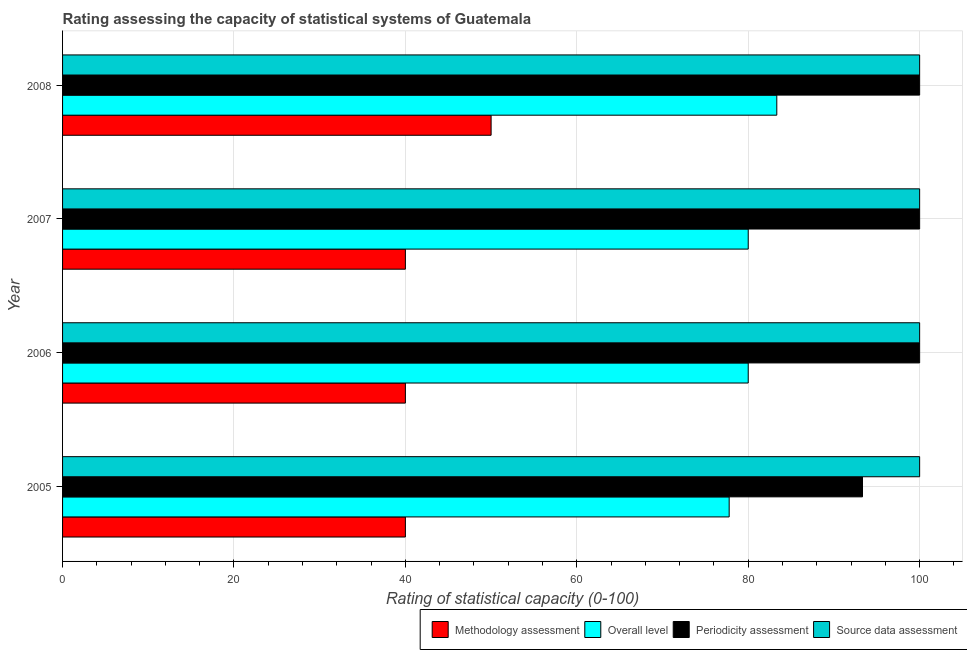How many groups of bars are there?
Ensure brevity in your answer.  4. Are the number of bars per tick equal to the number of legend labels?
Make the answer very short. Yes. Are the number of bars on each tick of the Y-axis equal?
Keep it short and to the point. Yes. How many bars are there on the 2nd tick from the bottom?
Offer a very short reply. 4. What is the label of the 4th group of bars from the top?
Your answer should be very brief. 2005. In how many cases, is the number of bars for a given year not equal to the number of legend labels?
Provide a short and direct response. 0. What is the source data assessment rating in 2008?
Your response must be concise. 100. Across all years, what is the maximum methodology assessment rating?
Ensure brevity in your answer.  50. Across all years, what is the minimum periodicity assessment rating?
Your answer should be compact. 93.33. In which year was the methodology assessment rating maximum?
Give a very brief answer. 2008. What is the total overall level rating in the graph?
Keep it short and to the point. 321.11. What is the difference between the source data assessment rating in 2006 and that in 2007?
Your answer should be compact. 0. What is the difference between the methodology assessment rating in 2005 and the overall level rating in 2006?
Offer a terse response. -40. In the year 2007, what is the difference between the periodicity assessment rating and methodology assessment rating?
Your answer should be very brief. 60. In how many years, is the periodicity assessment rating greater than 60 ?
Provide a short and direct response. 4. What is the ratio of the source data assessment rating in 2006 to that in 2007?
Make the answer very short. 1. What is the difference between the highest and the second highest overall level rating?
Your response must be concise. 3.33. What is the difference between the highest and the lowest periodicity assessment rating?
Keep it short and to the point. 6.67. In how many years, is the periodicity assessment rating greater than the average periodicity assessment rating taken over all years?
Provide a short and direct response. 3. What does the 1st bar from the top in 2007 represents?
Give a very brief answer. Source data assessment. What does the 1st bar from the bottom in 2006 represents?
Give a very brief answer. Methodology assessment. Are all the bars in the graph horizontal?
Ensure brevity in your answer.  Yes. How many years are there in the graph?
Your answer should be compact. 4. Are the values on the major ticks of X-axis written in scientific E-notation?
Provide a succinct answer. No. How are the legend labels stacked?
Offer a terse response. Horizontal. What is the title of the graph?
Provide a short and direct response. Rating assessing the capacity of statistical systems of Guatemala. What is the label or title of the X-axis?
Your answer should be compact. Rating of statistical capacity (0-100). What is the label or title of the Y-axis?
Give a very brief answer. Year. What is the Rating of statistical capacity (0-100) in Methodology assessment in 2005?
Your response must be concise. 40. What is the Rating of statistical capacity (0-100) of Overall level in 2005?
Keep it short and to the point. 77.78. What is the Rating of statistical capacity (0-100) in Periodicity assessment in 2005?
Make the answer very short. 93.33. What is the Rating of statistical capacity (0-100) in Overall level in 2006?
Ensure brevity in your answer.  80. What is the Rating of statistical capacity (0-100) in Periodicity assessment in 2006?
Offer a very short reply. 100. What is the Rating of statistical capacity (0-100) in Source data assessment in 2006?
Make the answer very short. 100. What is the Rating of statistical capacity (0-100) in Periodicity assessment in 2007?
Keep it short and to the point. 100. What is the Rating of statistical capacity (0-100) in Methodology assessment in 2008?
Offer a very short reply. 50. What is the Rating of statistical capacity (0-100) of Overall level in 2008?
Offer a terse response. 83.33. What is the Rating of statistical capacity (0-100) in Source data assessment in 2008?
Ensure brevity in your answer.  100. Across all years, what is the maximum Rating of statistical capacity (0-100) in Methodology assessment?
Make the answer very short. 50. Across all years, what is the maximum Rating of statistical capacity (0-100) in Overall level?
Your answer should be compact. 83.33. Across all years, what is the maximum Rating of statistical capacity (0-100) of Periodicity assessment?
Offer a terse response. 100. Across all years, what is the minimum Rating of statistical capacity (0-100) in Overall level?
Provide a succinct answer. 77.78. Across all years, what is the minimum Rating of statistical capacity (0-100) of Periodicity assessment?
Give a very brief answer. 93.33. What is the total Rating of statistical capacity (0-100) of Methodology assessment in the graph?
Provide a short and direct response. 170. What is the total Rating of statistical capacity (0-100) of Overall level in the graph?
Your answer should be very brief. 321.11. What is the total Rating of statistical capacity (0-100) in Periodicity assessment in the graph?
Your response must be concise. 393.33. What is the total Rating of statistical capacity (0-100) of Source data assessment in the graph?
Your answer should be very brief. 400. What is the difference between the Rating of statistical capacity (0-100) of Overall level in 2005 and that in 2006?
Keep it short and to the point. -2.22. What is the difference between the Rating of statistical capacity (0-100) of Periodicity assessment in 2005 and that in 2006?
Keep it short and to the point. -6.67. What is the difference between the Rating of statistical capacity (0-100) in Source data assessment in 2005 and that in 2006?
Your response must be concise. 0. What is the difference between the Rating of statistical capacity (0-100) of Overall level in 2005 and that in 2007?
Your answer should be very brief. -2.22. What is the difference between the Rating of statistical capacity (0-100) of Periodicity assessment in 2005 and that in 2007?
Your answer should be very brief. -6.67. What is the difference between the Rating of statistical capacity (0-100) of Methodology assessment in 2005 and that in 2008?
Ensure brevity in your answer.  -10. What is the difference between the Rating of statistical capacity (0-100) in Overall level in 2005 and that in 2008?
Your answer should be very brief. -5.56. What is the difference between the Rating of statistical capacity (0-100) in Periodicity assessment in 2005 and that in 2008?
Ensure brevity in your answer.  -6.67. What is the difference between the Rating of statistical capacity (0-100) in Source data assessment in 2005 and that in 2008?
Give a very brief answer. 0. What is the difference between the Rating of statistical capacity (0-100) in Periodicity assessment in 2006 and that in 2007?
Offer a terse response. 0. What is the difference between the Rating of statistical capacity (0-100) of Methodology assessment in 2006 and that in 2008?
Provide a succinct answer. -10. What is the difference between the Rating of statistical capacity (0-100) in Overall level in 2006 and that in 2008?
Provide a succinct answer. -3.33. What is the difference between the Rating of statistical capacity (0-100) in Source data assessment in 2006 and that in 2008?
Your answer should be compact. 0. What is the difference between the Rating of statistical capacity (0-100) of Methodology assessment in 2007 and that in 2008?
Ensure brevity in your answer.  -10. What is the difference between the Rating of statistical capacity (0-100) of Source data assessment in 2007 and that in 2008?
Ensure brevity in your answer.  0. What is the difference between the Rating of statistical capacity (0-100) in Methodology assessment in 2005 and the Rating of statistical capacity (0-100) in Overall level in 2006?
Your response must be concise. -40. What is the difference between the Rating of statistical capacity (0-100) of Methodology assessment in 2005 and the Rating of statistical capacity (0-100) of Periodicity assessment in 2006?
Your response must be concise. -60. What is the difference between the Rating of statistical capacity (0-100) in Methodology assessment in 2005 and the Rating of statistical capacity (0-100) in Source data assessment in 2006?
Your answer should be very brief. -60. What is the difference between the Rating of statistical capacity (0-100) of Overall level in 2005 and the Rating of statistical capacity (0-100) of Periodicity assessment in 2006?
Your answer should be very brief. -22.22. What is the difference between the Rating of statistical capacity (0-100) of Overall level in 2005 and the Rating of statistical capacity (0-100) of Source data assessment in 2006?
Your response must be concise. -22.22. What is the difference between the Rating of statistical capacity (0-100) of Periodicity assessment in 2005 and the Rating of statistical capacity (0-100) of Source data assessment in 2006?
Give a very brief answer. -6.67. What is the difference between the Rating of statistical capacity (0-100) in Methodology assessment in 2005 and the Rating of statistical capacity (0-100) in Periodicity assessment in 2007?
Your answer should be very brief. -60. What is the difference between the Rating of statistical capacity (0-100) in Methodology assessment in 2005 and the Rating of statistical capacity (0-100) in Source data assessment in 2007?
Ensure brevity in your answer.  -60. What is the difference between the Rating of statistical capacity (0-100) in Overall level in 2005 and the Rating of statistical capacity (0-100) in Periodicity assessment in 2007?
Your answer should be compact. -22.22. What is the difference between the Rating of statistical capacity (0-100) of Overall level in 2005 and the Rating of statistical capacity (0-100) of Source data assessment in 2007?
Ensure brevity in your answer.  -22.22. What is the difference between the Rating of statistical capacity (0-100) in Periodicity assessment in 2005 and the Rating of statistical capacity (0-100) in Source data assessment in 2007?
Offer a terse response. -6.67. What is the difference between the Rating of statistical capacity (0-100) of Methodology assessment in 2005 and the Rating of statistical capacity (0-100) of Overall level in 2008?
Ensure brevity in your answer.  -43.33. What is the difference between the Rating of statistical capacity (0-100) in Methodology assessment in 2005 and the Rating of statistical capacity (0-100) in Periodicity assessment in 2008?
Ensure brevity in your answer.  -60. What is the difference between the Rating of statistical capacity (0-100) of Methodology assessment in 2005 and the Rating of statistical capacity (0-100) of Source data assessment in 2008?
Provide a succinct answer. -60. What is the difference between the Rating of statistical capacity (0-100) of Overall level in 2005 and the Rating of statistical capacity (0-100) of Periodicity assessment in 2008?
Offer a very short reply. -22.22. What is the difference between the Rating of statistical capacity (0-100) in Overall level in 2005 and the Rating of statistical capacity (0-100) in Source data assessment in 2008?
Your answer should be compact. -22.22. What is the difference between the Rating of statistical capacity (0-100) in Periodicity assessment in 2005 and the Rating of statistical capacity (0-100) in Source data assessment in 2008?
Your response must be concise. -6.67. What is the difference between the Rating of statistical capacity (0-100) of Methodology assessment in 2006 and the Rating of statistical capacity (0-100) of Periodicity assessment in 2007?
Ensure brevity in your answer.  -60. What is the difference between the Rating of statistical capacity (0-100) in Methodology assessment in 2006 and the Rating of statistical capacity (0-100) in Source data assessment in 2007?
Keep it short and to the point. -60. What is the difference between the Rating of statistical capacity (0-100) of Overall level in 2006 and the Rating of statistical capacity (0-100) of Periodicity assessment in 2007?
Provide a succinct answer. -20. What is the difference between the Rating of statistical capacity (0-100) of Overall level in 2006 and the Rating of statistical capacity (0-100) of Source data assessment in 2007?
Give a very brief answer. -20. What is the difference between the Rating of statistical capacity (0-100) in Methodology assessment in 2006 and the Rating of statistical capacity (0-100) in Overall level in 2008?
Provide a succinct answer. -43.33. What is the difference between the Rating of statistical capacity (0-100) in Methodology assessment in 2006 and the Rating of statistical capacity (0-100) in Periodicity assessment in 2008?
Provide a succinct answer. -60. What is the difference between the Rating of statistical capacity (0-100) of Methodology assessment in 2006 and the Rating of statistical capacity (0-100) of Source data assessment in 2008?
Offer a terse response. -60. What is the difference between the Rating of statistical capacity (0-100) of Overall level in 2006 and the Rating of statistical capacity (0-100) of Periodicity assessment in 2008?
Make the answer very short. -20. What is the difference between the Rating of statistical capacity (0-100) in Overall level in 2006 and the Rating of statistical capacity (0-100) in Source data assessment in 2008?
Your answer should be compact. -20. What is the difference between the Rating of statistical capacity (0-100) in Methodology assessment in 2007 and the Rating of statistical capacity (0-100) in Overall level in 2008?
Offer a terse response. -43.33. What is the difference between the Rating of statistical capacity (0-100) in Methodology assessment in 2007 and the Rating of statistical capacity (0-100) in Periodicity assessment in 2008?
Keep it short and to the point. -60. What is the difference between the Rating of statistical capacity (0-100) in Methodology assessment in 2007 and the Rating of statistical capacity (0-100) in Source data assessment in 2008?
Provide a succinct answer. -60. What is the difference between the Rating of statistical capacity (0-100) in Overall level in 2007 and the Rating of statistical capacity (0-100) in Source data assessment in 2008?
Provide a short and direct response. -20. What is the difference between the Rating of statistical capacity (0-100) of Periodicity assessment in 2007 and the Rating of statistical capacity (0-100) of Source data assessment in 2008?
Keep it short and to the point. 0. What is the average Rating of statistical capacity (0-100) of Methodology assessment per year?
Offer a terse response. 42.5. What is the average Rating of statistical capacity (0-100) of Overall level per year?
Ensure brevity in your answer.  80.28. What is the average Rating of statistical capacity (0-100) in Periodicity assessment per year?
Provide a short and direct response. 98.33. In the year 2005, what is the difference between the Rating of statistical capacity (0-100) in Methodology assessment and Rating of statistical capacity (0-100) in Overall level?
Your answer should be compact. -37.78. In the year 2005, what is the difference between the Rating of statistical capacity (0-100) of Methodology assessment and Rating of statistical capacity (0-100) of Periodicity assessment?
Make the answer very short. -53.33. In the year 2005, what is the difference between the Rating of statistical capacity (0-100) in Methodology assessment and Rating of statistical capacity (0-100) in Source data assessment?
Make the answer very short. -60. In the year 2005, what is the difference between the Rating of statistical capacity (0-100) in Overall level and Rating of statistical capacity (0-100) in Periodicity assessment?
Offer a very short reply. -15.56. In the year 2005, what is the difference between the Rating of statistical capacity (0-100) in Overall level and Rating of statistical capacity (0-100) in Source data assessment?
Provide a succinct answer. -22.22. In the year 2005, what is the difference between the Rating of statistical capacity (0-100) of Periodicity assessment and Rating of statistical capacity (0-100) of Source data assessment?
Your answer should be compact. -6.67. In the year 2006, what is the difference between the Rating of statistical capacity (0-100) of Methodology assessment and Rating of statistical capacity (0-100) of Overall level?
Ensure brevity in your answer.  -40. In the year 2006, what is the difference between the Rating of statistical capacity (0-100) of Methodology assessment and Rating of statistical capacity (0-100) of Periodicity assessment?
Your answer should be very brief. -60. In the year 2006, what is the difference between the Rating of statistical capacity (0-100) in Methodology assessment and Rating of statistical capacity (0-100) in Source data assessment?
Your answer should be very brief. -60. In the year 2006, what is the difference between the Rating of statistical capacity (0-100) of Overall level and Rating of statistical capacity (0-100) of Source data assessment?
Your answer should be compact. -20. In the year 2006, what is the difference between the Rating of statistical capacity (0-100) of Periodicity assessment and Rating of statistical capacity (0-100) of Source data assessment?
Offer a terse response. 0. In the year 2007, what is the difference between the Rating of statistical capacity (0-100) in Methodology assessment and Rating of statistical capacity (0-100) in Overall level?
Your answer should be very brief. -40. In the year 2007, what is the difference between the Rating of statistical capacity (0-100) of Methodology assessment and Rating of statistical capacity (0-100) of Periodicity assessment?
Your response must be concise. -60. In the year 2007, what is the difference between the Rating of statistical capacity (0-100) in Methodology assessment and Rating of statistical capacity (0-100) in Source data assessment?
Provide a short and direct response. -60. In the year 2007, what is the difference between the Rating of statistical capacity (0-100) in Overall level and Rating of statistical capacity (0-100) in Periodicity assessment?
Provide a succinct answer. -20. In the year 2007, what is the difference between the Rating of statistical capacity (0-100) in Overall level and Rating of statistical capacity (0-100) in Source data assessment?
Offer a terse response. -20. In the year 2008, what is the difference between the Rating of statistical capacity (0-100) in Methodology assessment and Rating of statistical capacity (0-100) in Overall level?
Ensure brevity in your answer.  -33.33. In the year 2008, what is the difference between the Rating of statistical capacity (0-100) in Methodology assessment and Rating of statistical capacity (0-100) in Periodicity assessment?
Your answer should be compact. -50. In the year 2008, what is the difference between the Rating of statistical capacity (0-100) of Overall level and Rating of statistical capacity (0-100) of Periodicity assessment?
Offer a terse response. -16.67. In the year 2008, what is the difference between the Rating of statistical capacity (0-100) in Overall level and Rating of statistical capacity (0-100) in Source data assessment?
Offer a very short reply. -16.67. In the year 2008, what is the difference between the Rating of statistical capacity (0-100) in Periodicity assessment and Rating of statistical capacity (0-100) in Source data assessment?
Ensure brevity in your answer.  0. What is the ratio of the Rating of statistical capacity (0-100) in Methodology assessment in 2005 to that in 2006?
Provide a short and direct response. 1. What is the ratio of the Rating of statistical capacity (0-100) of Overall level in 2005 to that in 2006?
Offer a very short reply. 0.97. What is the ratio of the Rating of statistical capacity (0-100) of Overall level in 2005 to that in 2007?
Your answer should be compact. 0.97. What is the ratio of the Rating of statistical capacity (0-100) of Periodicity assessment in 2005 to that in 2007?
Give a very brief answer. 0.93. What is the ratio of the Rating of statistical capacity (0-100) in Source data assessment in 2005 to that in 2007?
Make the answer very short. 1. What is the ratio of the Rating of statistical capacity (0-100) in Methodology assessment in 2005 to that in 2008?
Provide a short and direct response. 0.8. What is the ratio of the Rating of statistical capacity (0-100) in Periodicity assessment in 2005 to that in 2008?
Your answer should be very brief. 0.93. What is the ratio of the Rating of statistical capacity (0-100) of Source data assessment in 2005 to that in 2008?
Ensure brevity in your answer.  1. What is the ratio of the Rating of statistical capacity (0-100) of Methodology assessment in 2006 to that in 2007?
Ensure brevity in your answer.  1. What is the ratio of the Rating of statistical capacity (0-100) of Overall level in 2006 to that in 2007?
Keep it short and to the point. 1. What is the ratio of the Rating of statistical capacity (0-100) of Methodology assessment in 2006 to that in 2008?
Offer a terse response. 0.8. What is the ratio of the Rating of statistical capacity (0-100) in Overall level in 2006 to that in 2008?
Keep it short and to the point. 0.96. What is the ratio of the Rating of statistical capacity (0-100) in Periodicity assessment in 2006 to that in 2008?
Your answer should be very brief. 1. What is the ratio of the Rating of statistical capacity (0-100) in Overall level in 2007 to that in 2008?
Your response must be concise. 0.96. What is the ratio of the Rating of statistical capacity (0-100) in Source data assessment in 2007 to that in 2008?
Give a very brief answer. 1. What is the difference between the highest and the second highest Rating of statistical capacity (0-100) of Methodology assessment?
Offer a terse response. 10. What is the difference between the highest and the second highest Rating of statistical capacity (0-100) in Overall level?
Provide a succinct answer. 3.33. What is the difference between the highest and the lowest Rating of statistical capacity (0-100) in Methodology assessment?
Your response must be concise. 10. What is the difference between the highest and the lowest Rating of statistical capacity (0-100) of Overall level?
Keep it short and to the point. 5.56. What is the difference between the highest and the lowest Rating of statistical capacity (0-100) of Periodicity assessment?
Keep it short and to the point. 6.67. What is the difference between the highest and the lowest Rating of statistical capacity (0-100) in Source data assessment?
Provide a short and direct response. 0. 